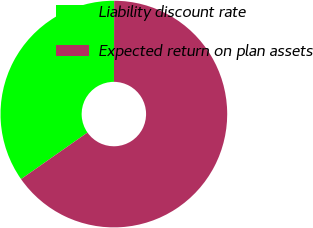<chart> <loc_0><loc_0><loc_500><loc_500><pie_chart><fcel>Liability discount rate<fcel>Expected return on plan assets<nl><fcel>34.78%<fcel>65.22%<nl></chart> 